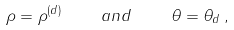Convert formula to latex. <formula><loc_0><loc_0><loc_500><loc_500>\rho = \rho ^ { ( d ) } \, \quad a n d \quad \, \theta = \theta _ { d } \, ,</formula> 